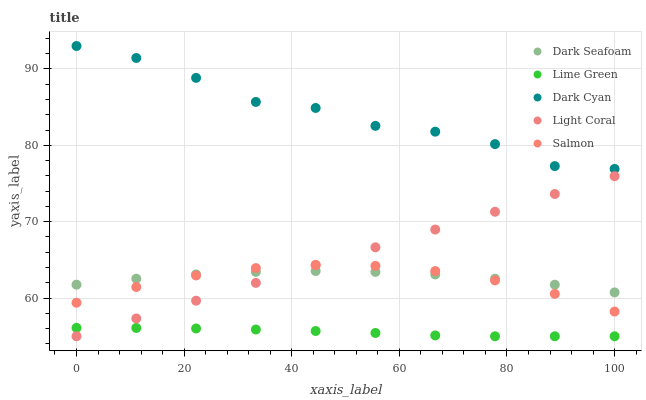Does Lime Green have the minimum area under the curve?
Answer yes or no. Yes. Does Dark Cyan have the maximum area under the curve?
Answer yes or no. Yes. Does Light Coral have the minimum area under the curve?
Answer yes or no. No. Does Light Coral have the maximum area under the curve?
Answer yes or no. No. Is Light Coral the smoothest?
Answer yes or no. Yes. Is Dark Cyan the roughest?
Answer yes or no. Yes. Is Dark Seafoam the smoothest?
Answer yes or no. No. Is Dark Seafoam the roughest?
Answer yes or no. No. Does Light Coral have the lowest value?
Answer yes or no. Yes. Does Dark Seafoam have the lowest value?
Answer yes or no. No. Does Dark Cyan have the highest value?
Answer yes or no. Yes. Does Light Coral have the highest value?
Answer yes or no. No. Is Lime Green less than Dark Cyan?
Answer yes or no. Yes. Is Dark Cyan greater than Light Coral?
Answer yes or no. Yes. Does Light Coral intersect Dark Seafoam?
Answer yes or no. Yes. Is Light Coral less than Dark Seafoam?
Answer yes or no. No. Is Light Coral greater than Dark Seafoam?
Answer yes or no. No. Does Lime Green intersect Dark Cyan?
Answer yes or no. No. 